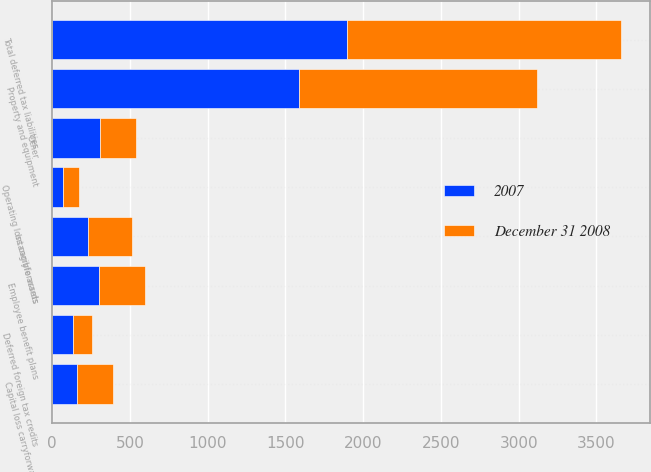Convert chart to OTSL. <chart><loc_0><loc_0><loc_500><loc_500><stacked_bar_chart><ecel><fcel>Property and equipment<fcel>Other<fcel>Total deferred tax liabilities<fcel>Employee benefit plans<fcel>Intangible assets<fcel>Capital loss carryforwards<fcel>Deferred foreign tax credits<fcel>Operating loss carryforwards<nl><fcel>2007<fcel>1587.5<fcel>308.1<fcel>1895.6<fcel>300.9<fcel>227.8<fcel>161.9<fcel>131.1<fcel>70.9<nl><fcel>December 31 2008<fcel>1532.7<fcel>231.8<fcel>1764.5<fcel>292.8<fcel>282.4<fcel>228.3<fcel>127.2<fcel>102.6<nl></chart> 